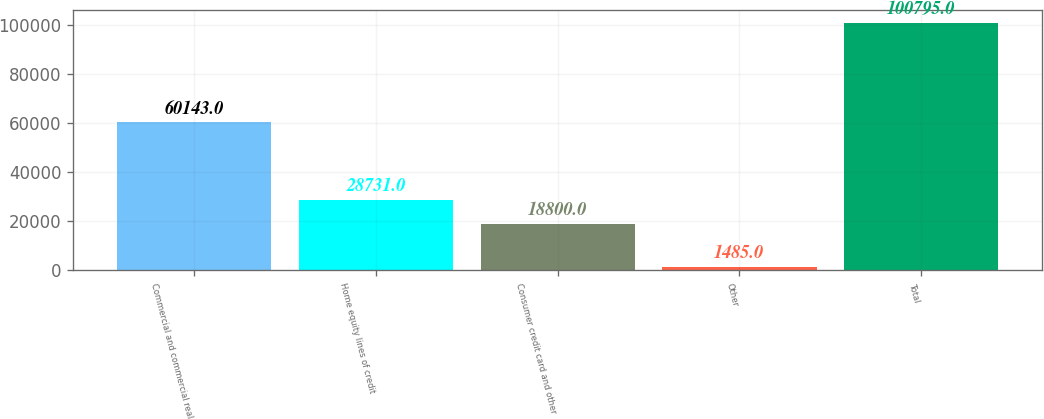Convert chart. <chart><loc_0><loc_0><loc_500><loc_500><bar_chart><fcel>Commercial and commercial real<fcel>Home equity lines of credit<fcel>Consumer credit card and other<fcel>Other<fcel>Total<nl><fcel>60143<fcel>28731<fcel>18800<fcel>1485<fcel>100795<nl></chart> 